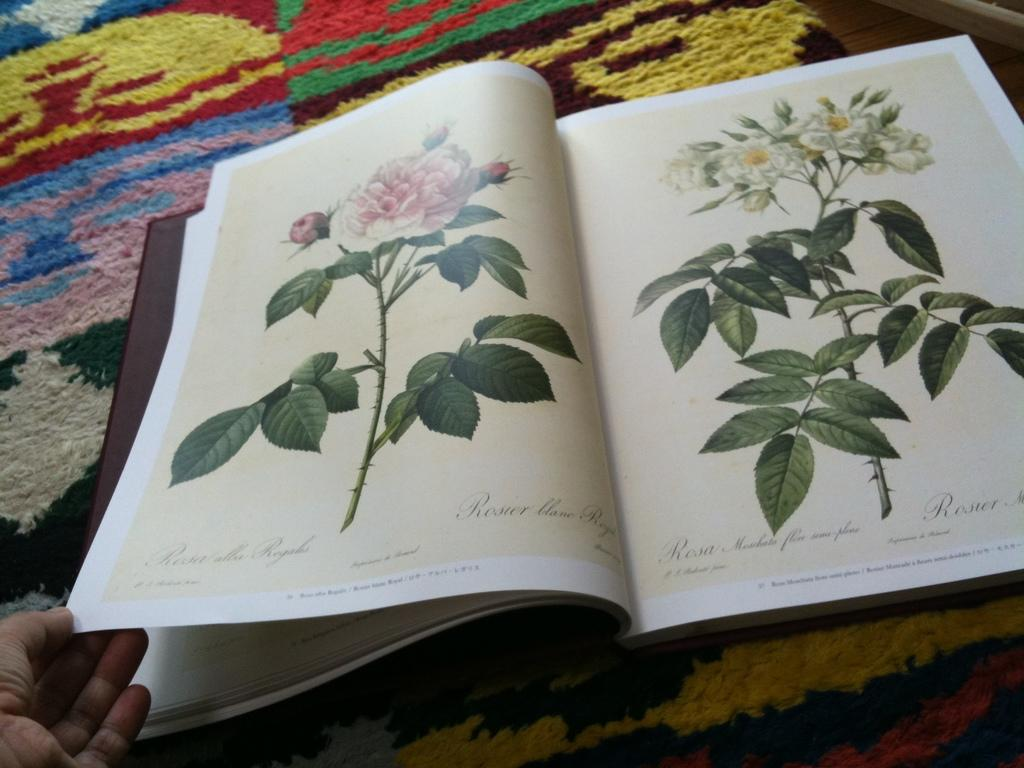<image>
Write a terse but informative summary of the picture. A book sitting on a rug showing flowers says Rosier on it. 